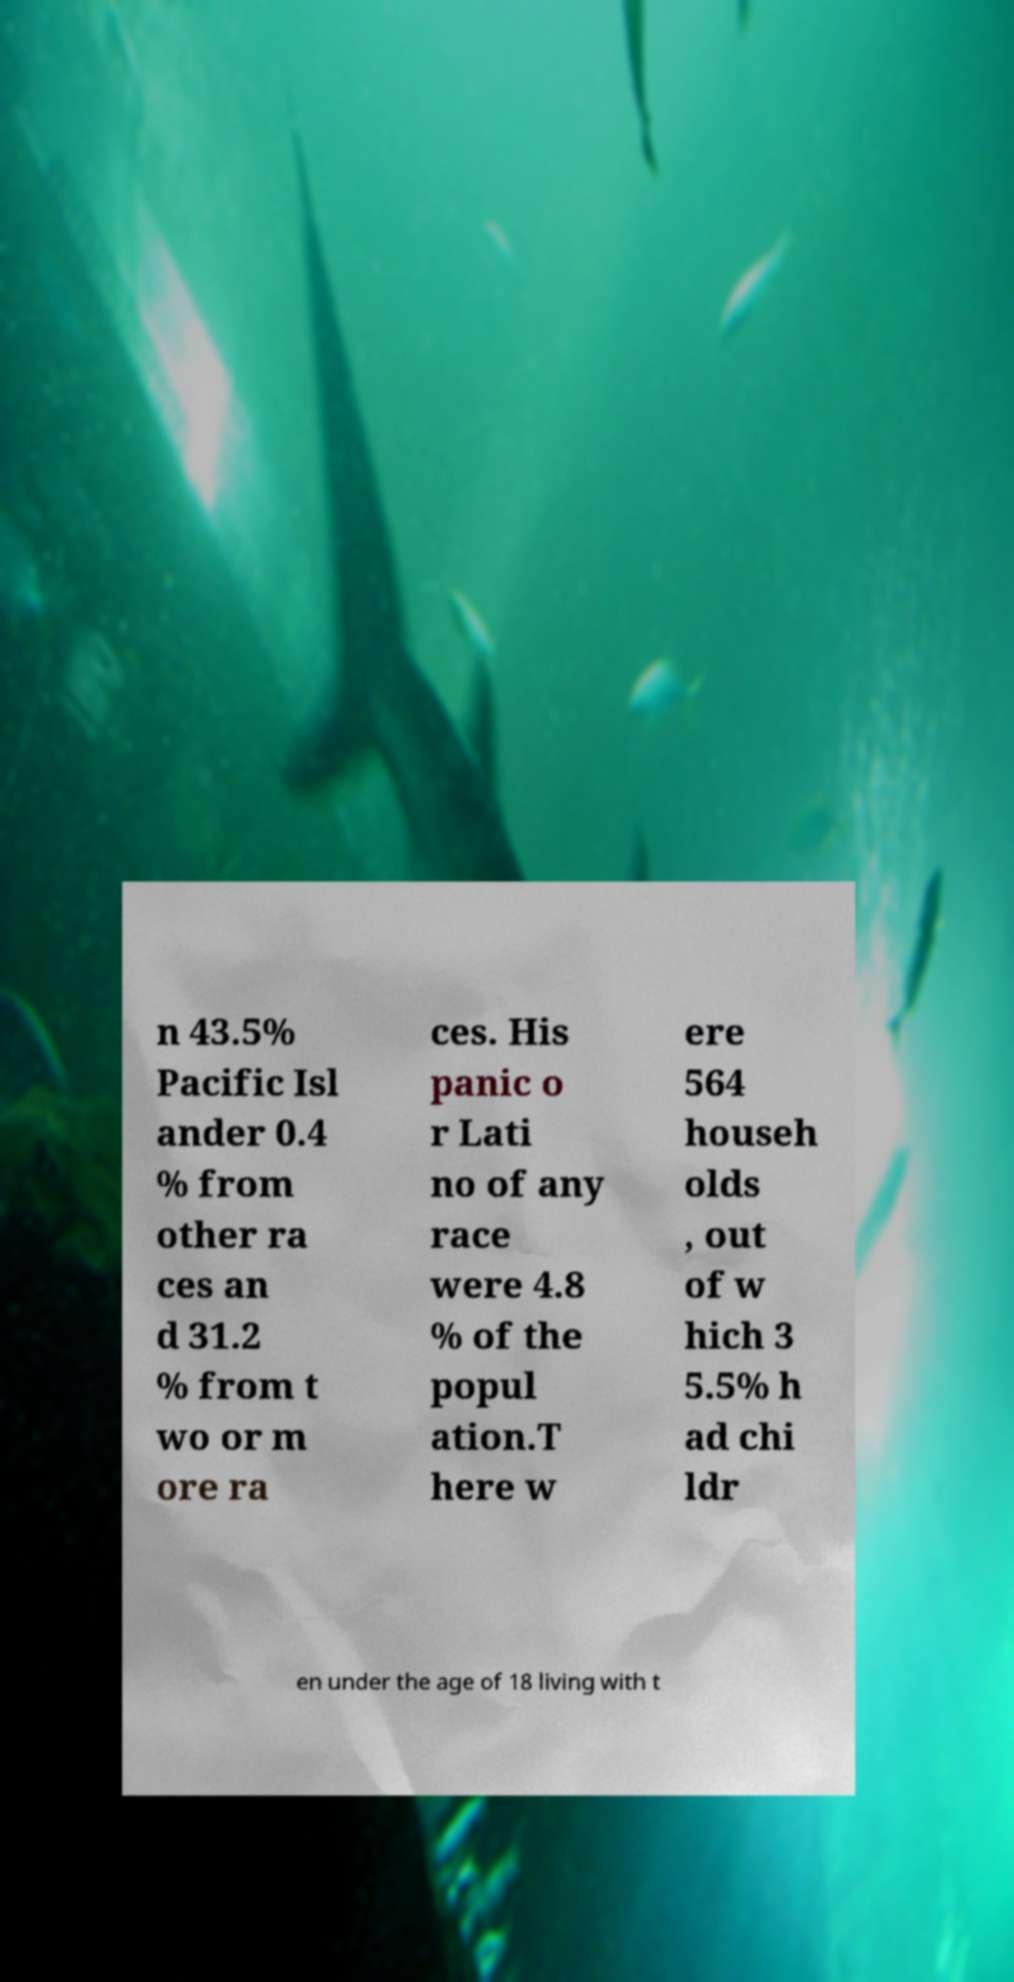There's text embedded in this image that I need extracted. Can you transcribe it verbatim? n 43.5% Pacific Isl ander 0.4 % from other ra ces an d 31.2 % from t wo or m ore ra ces. His panic o r Lati no of any race were 4.8 % of the popul ation.T here w ere 564 househ olds , out of w hich 3 5.5% h ad chi ldr en under the age of 18 living with t 